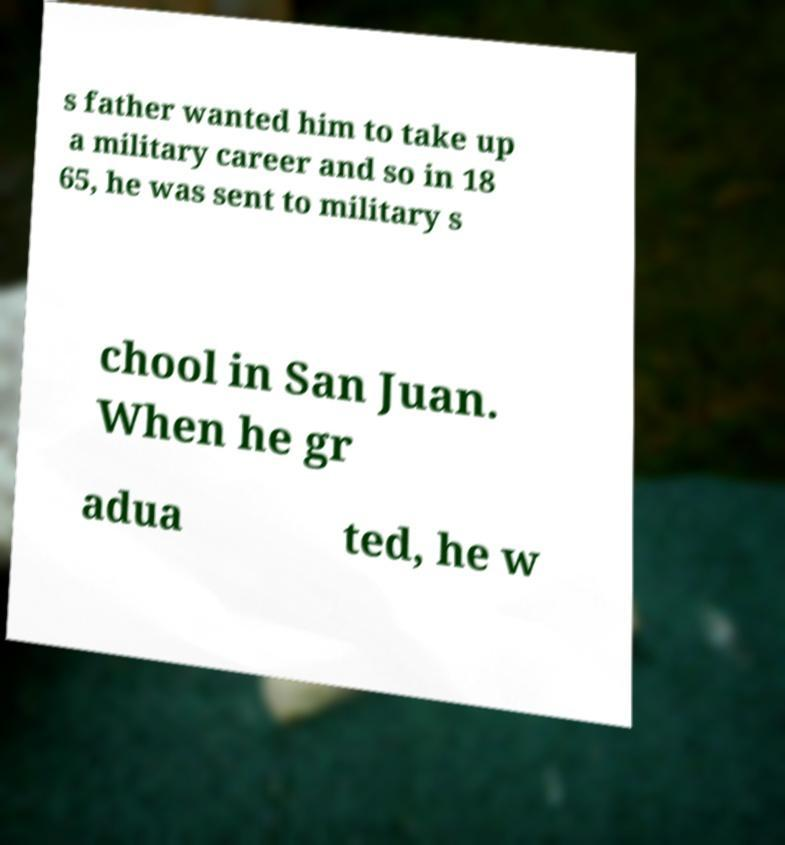Could you extract and type out the text from this image? s father wanted him to take up a military career and so in 18 65, he was sent to military s chool in San Juan. When he gr adua ted, he w 